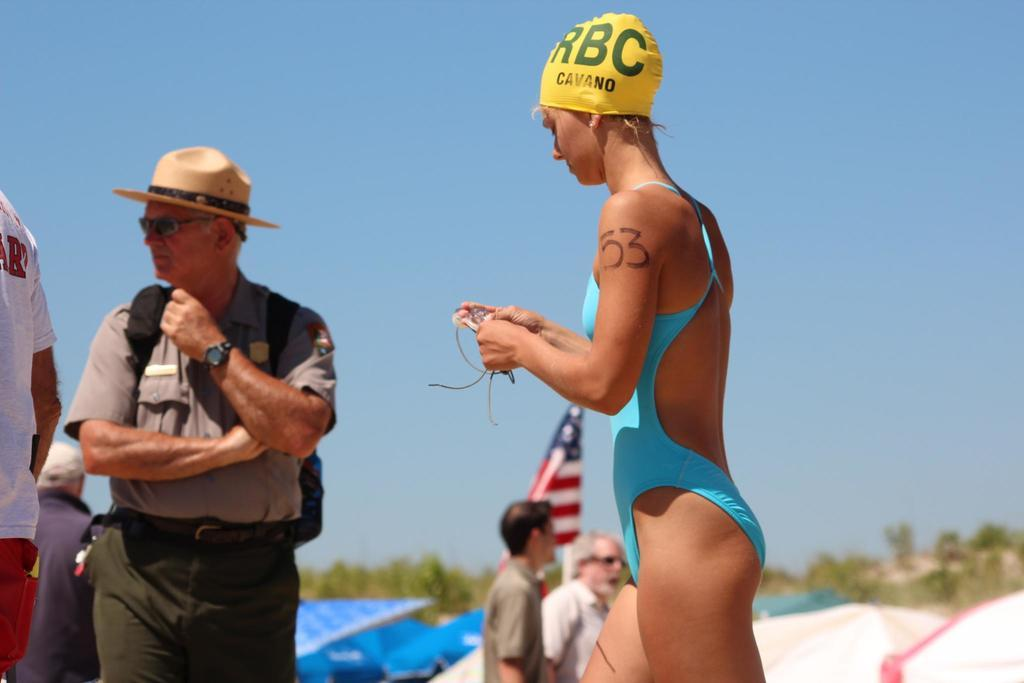What are the main subjects in the center of the image? There are persons standing in the center of the image. What can be seen in the background of the image? There are trees and umbrellas in the background of the image. What is visible in the sky in the background of the image? The sky is visible in the background of the image. What type of blade can be seen in the image? There is no blade present in the image. 